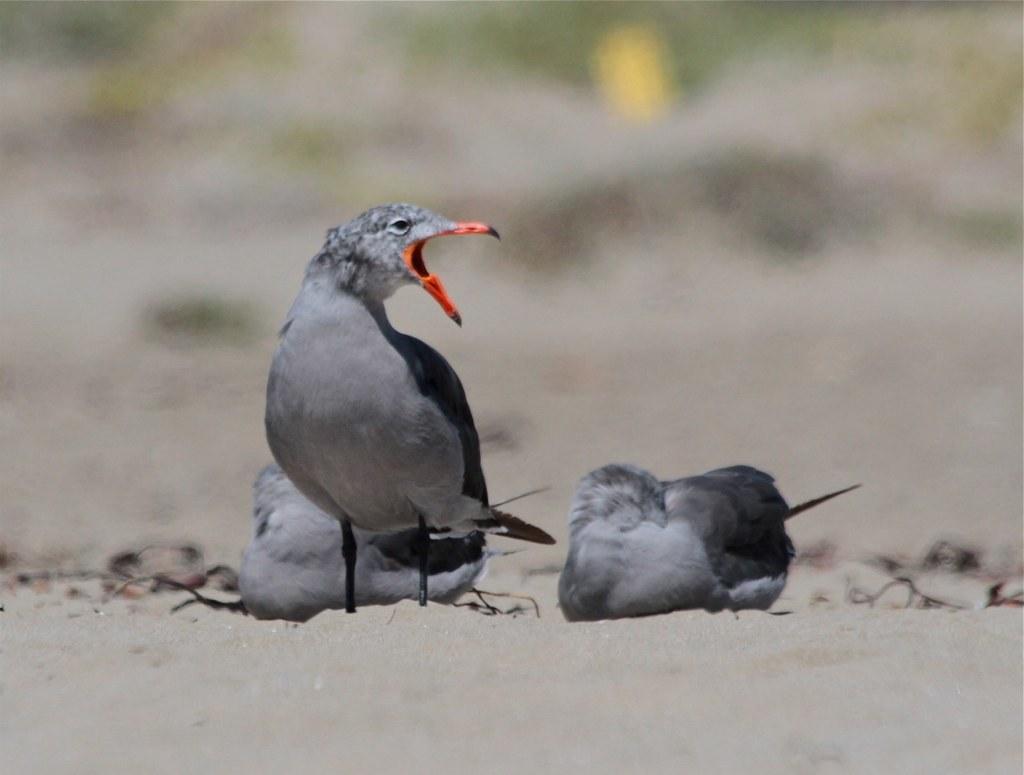How would you summarize this image in a sentence or two? In this image I can see few grey colour birds on ground. I can see this image is blurry from background. 